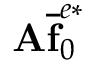<formula> <loc_0><loc_0><loc_500><loc_500>A \overline { f } _ { 0 } ^ { e * }</formula> 